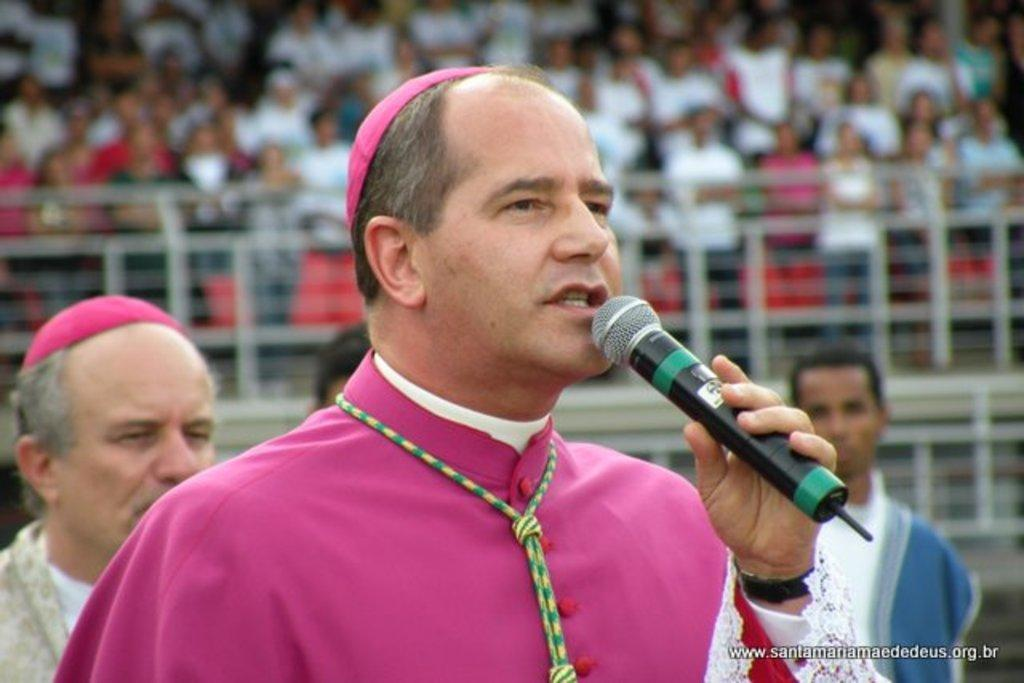How many people are visible in the image? There are people standing in the image. What is one person holding in their hand? One person is holding a mic in their hand. What type of scarf is being used to balance the giants in the image? There are no giants or scarves present in the image. 